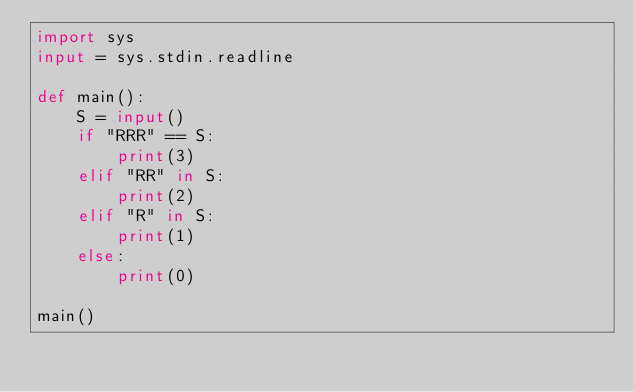<code> <loc_0><loc_0><loc_500><loc_500><_Python_>import sys
input = sys.stdin.readline

def main():
    S = input()
    if "RRR" == S:
        print(3)
    elif "RR" in S:
        print(2)
    elif "R" in S:
        print(1)
    else:
        print(0)

main()</code> 